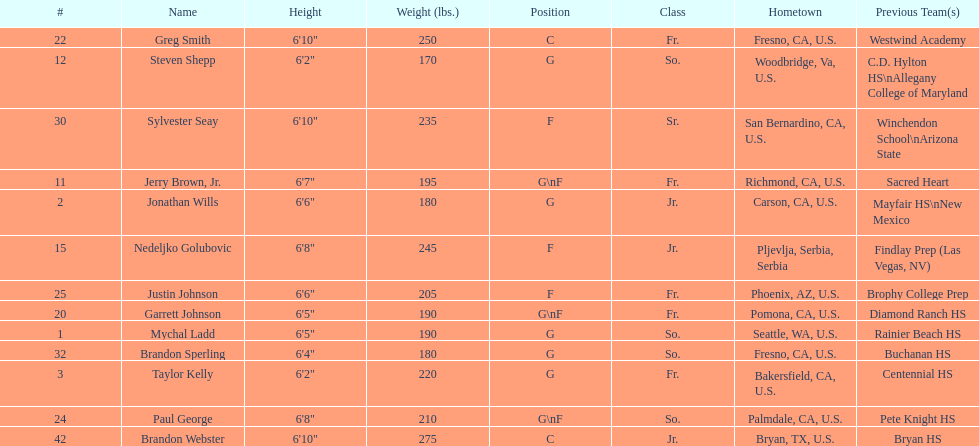Who weighs the most on the team? Brandon Webster. 